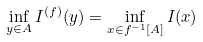<formula> <loc_0><loc_0><loc_500><loc_500>\inf _ { y \in A } I ^ { ( f ) } ( y ) = \inf _ { x \in f ^ { - 1 } [ A ] } I ( x )</formula> 